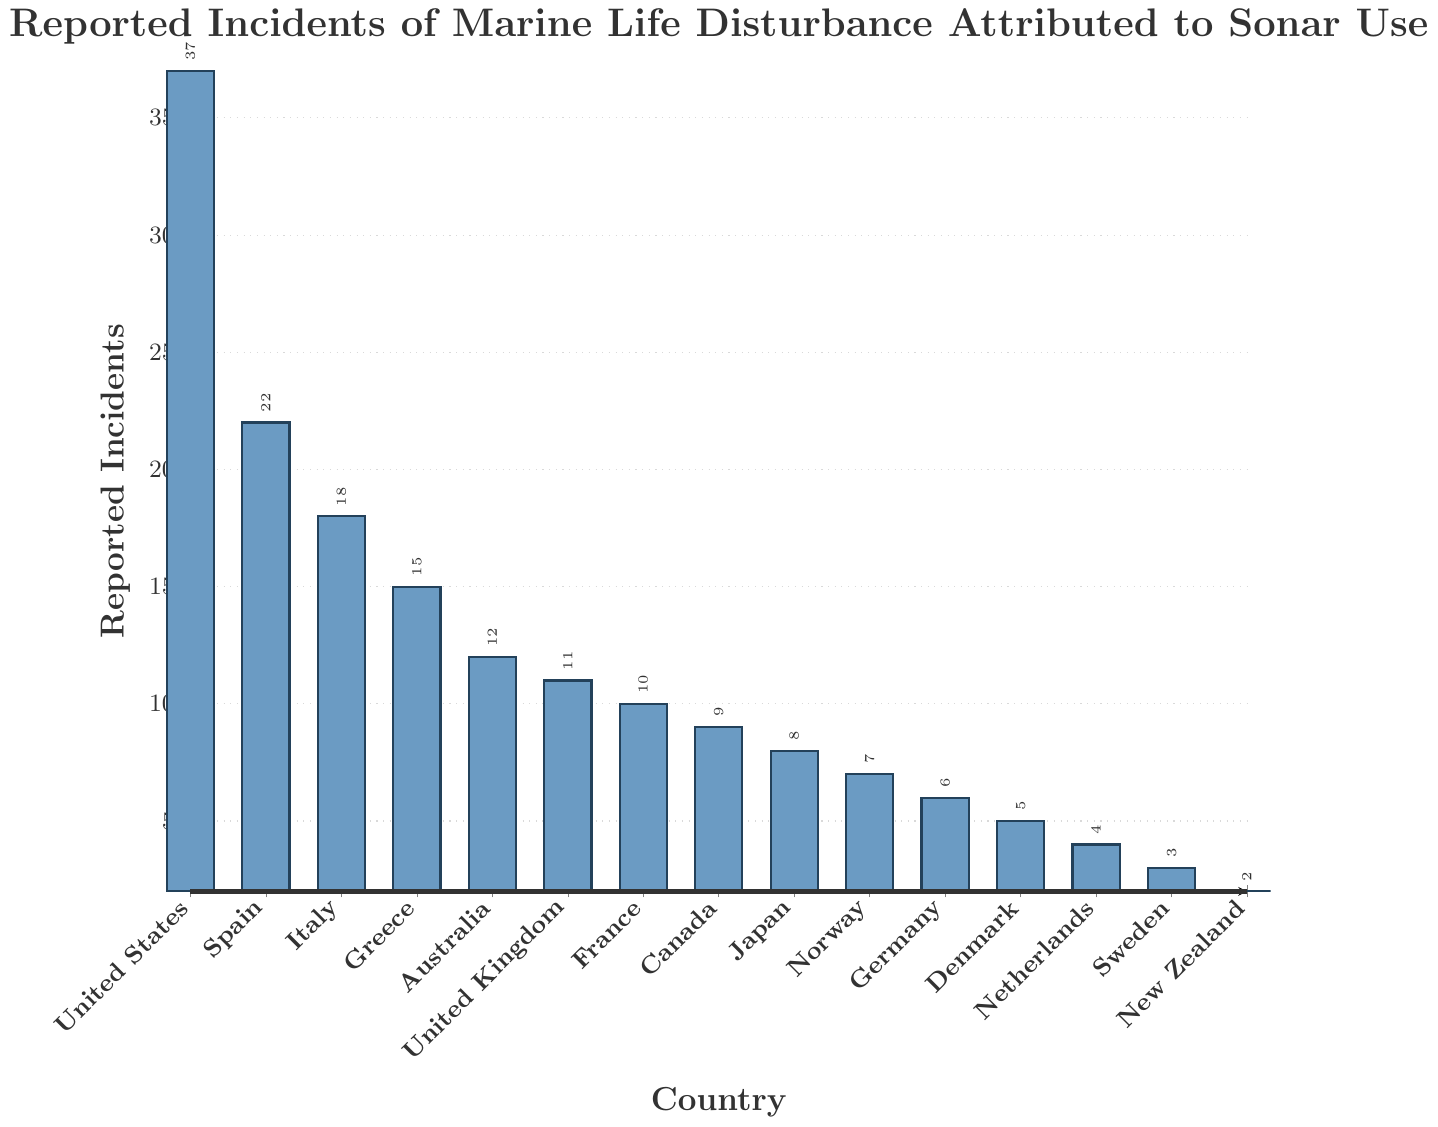What's the total number of reported incidents across all countries? To find the total, add the reported incidents for all countries: 37 (United States) + 22 (Spain) + 18 (Italy) + 15 (Greece) + 12 (Australia) + 11 (United Kingdom) + 10 (France) + 9 (Canada) + 8 (Japan) + 7 (Norway) + 6 (Germany) + 5 (Denmark) + 4 (Netherlands) + 3 (Sweden) + 2 (New Zealand). The sum is 169.
Answer: 169 Which country has the highest number of reported incidents? Identify the country with the tallest bar. The United States has the highest number of 37 reported incidents.
Answer: United States How many more reported incidents does the United States have compared to Canada? Subtract Canada's number of incidents from the United States' number: 37 (United States) - 9 (Canada) = 28.
Answer: 28 What is the average number of reported incidents across all countries? Sum the reported incidents for all countries (169) and divide by the number of countries (15): 169 ÷ 15 = 11.27.
Answer: 11.27 Rank the top three countries with the most reported incidents. The top three countries can be identified by their bar heights: 1. United States (37), 2. Spain (22), 3. Italy (18).
Answer: United States, Spain, Italy How many countries have fewer than 10 reported incidents? Count the countries with reported incidents less than 10: Canada (9), Japan (8), Norway (7), Germany (6), Denmark (5), Netherlands (4), Sweden (3), New Zealand (2). There are 8 countries.
Answer: 8 From the visual perspective, which country has a bar that's approximately half the height of the United States? Visually estimate half the height of the United States' bar (37). Greece, with a reported incident of 15, is closest to this approximation as 18 or 19 would be roughly half of 37.
Answer: Greece What's the difference in reported incidents between the country with the second highest and the third highest number of incidents? Spain (22) is second and Italy (18) is third. The difference is 22 - 18 = 4.
Answer: 4 Which countries have an equal number of reported incidents? Check for countries with bars of the same height: No countries have exactly the same number of reported incidents in the given data.
Answer: None Does France have more or fewer reported incidents than the United Kingdom? Compare the heights of the bars for France and the United Kingdom: France has 10, and the United Kingdom has 11. Hence, France has fewer reported incidents.
Answer: Fewer 